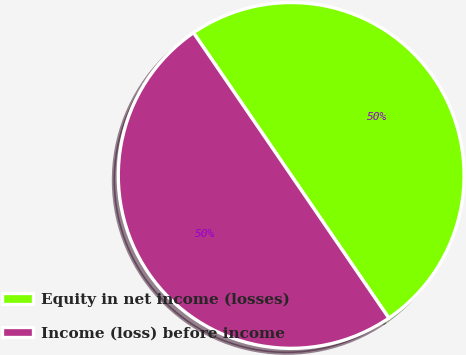Convert chart to OTSL. <chart><loc_0><loc_0><loc_500><loc_500><pie_chart><fcel>Equity in net income (losses)<fcel>Income (loss) before income<nl><fcel>50.0%<fcel>50.0%<nl></chart> 